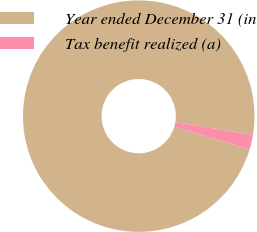<chart> <loc_0><loc_0><loc_500><loc_500><pie_chart><fcel>Year ended December 31 (in<fcel>Tax benefit realized (a)<nl><fcel>97.96%<fcel>2.04%<nl></chart> 